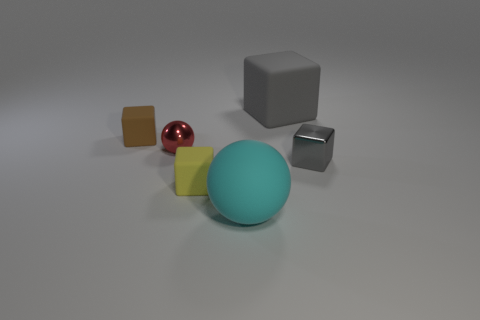How many gray blocks must be subtracted to get 1 gray blocks? 1 Add 3 tiny red shiny cubes. How many objects exist? 9 Subtract all green cylinders. How many gray blocks are left? 2 Subtract all big matte cubes. How many cubes are left? 3 Subtract 2 blocks. How many blocks are left? 2 Subtract all yellow cubes. How many cubes are left? 3 Subtract all balls. How many objects are left? 4 Subtract all red cubes. Subtract all red cylinders. How many cubes are left? 4 Subtract all small metal balls. Subtract all tiny gray metallic cubes. How many objects are left? 4 Add 5 rubber blocks. How many rubber blocks are left? 8 